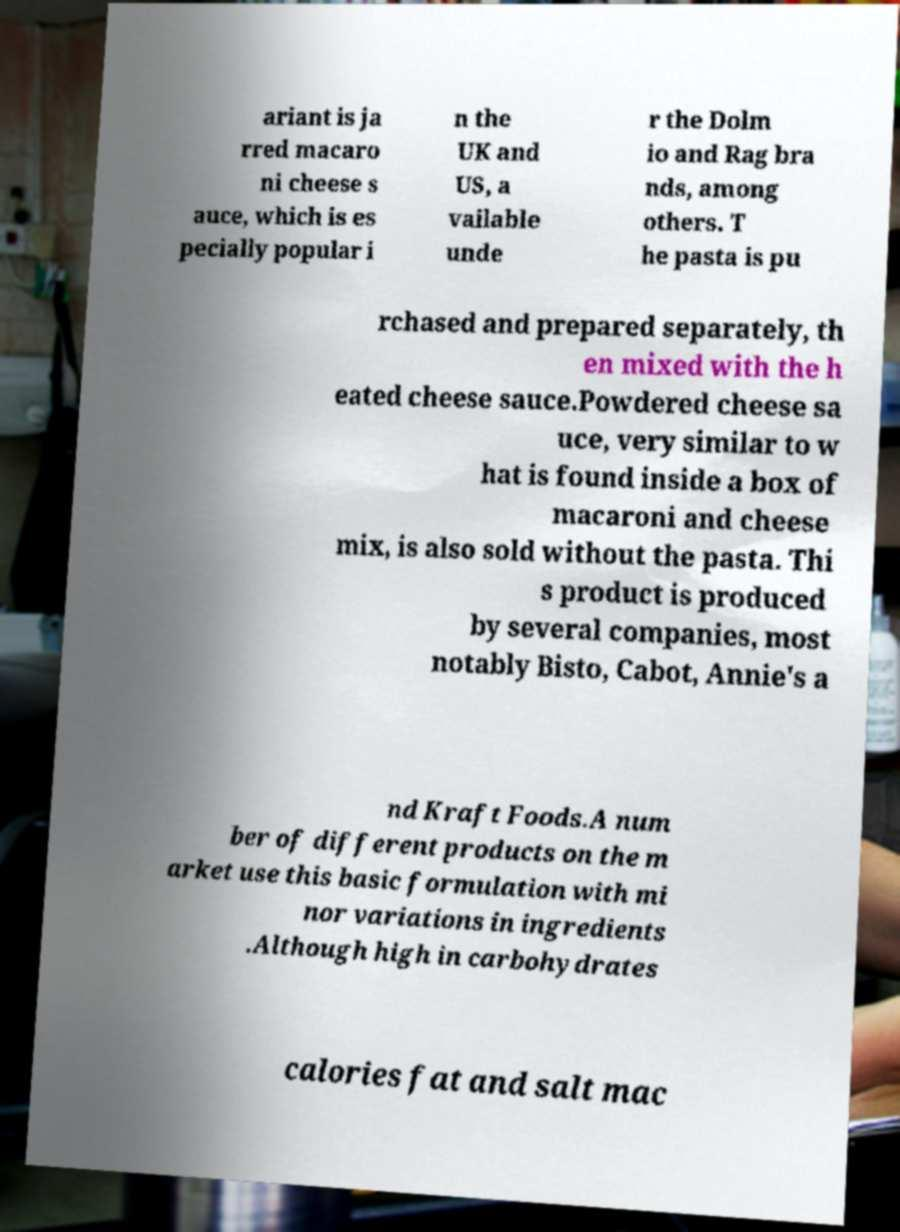Please read and relay the text visible in this image. What does it say? ariant is ja rred macaro ni cheese s auce, which is es pecially popular i n the UK and US, a vailable unde r the Dolm io and Rag bra nds, among others. T he pasta is pu rchased and prepared separately, th en mixed with the h eated cheese sauce.Powdered cheese sa uce, very similar to w hat is found inside a box of macaroni and cheese mix, is also sold without the pasta. Thi s product is produced by several companies, most notably Bisto, Cabot, Annie's a nd Kraft Foods.A num ber of different products on the m arket use this basic formulation with mi nor variations in ingredients .Although high in carbohydrates calories fat and salt mac 